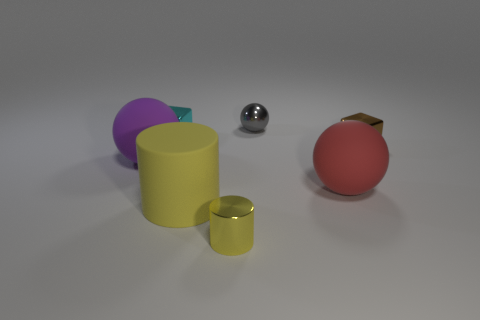What number of metallic objects are either large yellow objects or small red cubes?
Offer a terse response. 0. Are there any other gray balls made of the same material as the small sphere?
Provide a succinct answer. No. How many things are either large matte spheres that are to the right of the tiny gray ball or rubber spheres on the right side of the purple ball?
Give a very brief answer. 1. There is a metal thing that is in front of the big red rubber sphere; does it have the same color as the small metal ball?
Your answer should be very brief. No. What number of other objects are the same color as the metal cylinder?
Offer a very short reply. 1. What is the red object made of?
Ensure brevity in your answer.  Rubber. Do the sphere that is behind the purple matte sphere and the large red rubber object have the same size?
Offer a terse response. No. Is there anything else that is the same size as the gray metal sphere?
Offer a terse response. Yes. What size is the other rubber thing that is the same shape as the large red object?
Give a very brief answer. Large. Are there an equal number of yellow cylinders right of the yellow rubber object and metal spheres in front of the big red matte ball?
Make the answer very short. No. 